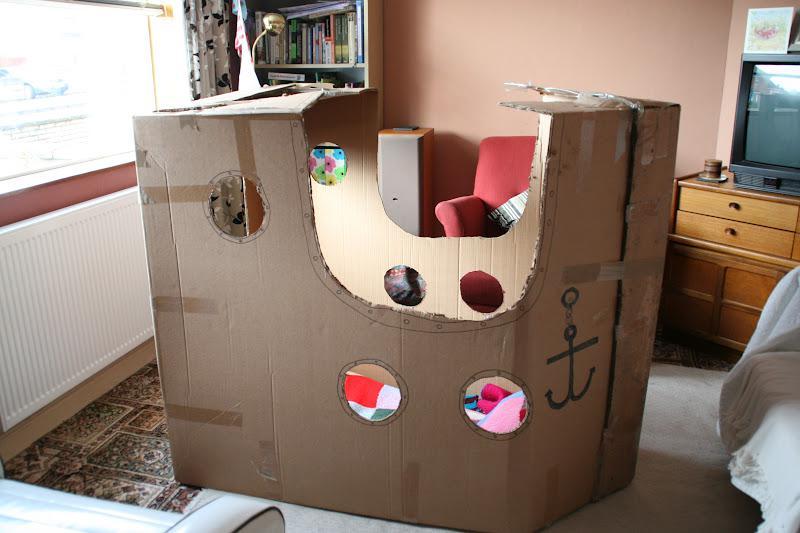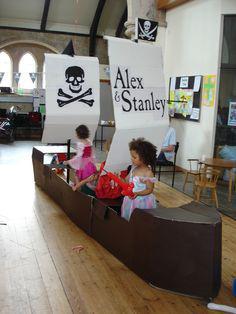The first image is the image on the left, the second image is the image on the right. Given the left and right images, does the statement "The right image features at least one child inside a long boat made out of joined cardboard boxes." hold true? Answer yes or no. Yes. 